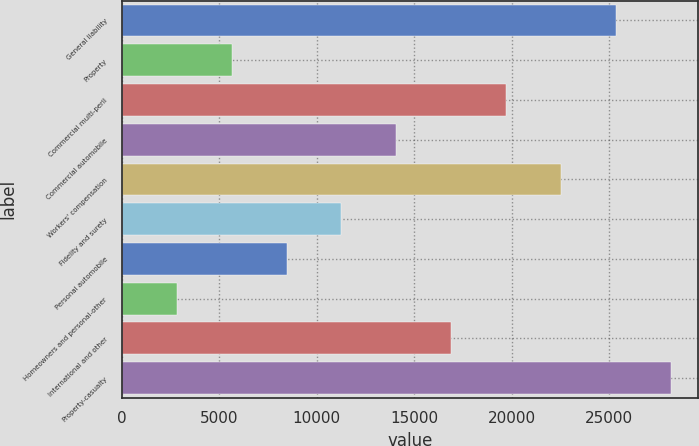Convert chart. <chart><loc_0><loc_0><loc_500><loc_500><bar_chart><fcel>General liability<fcel>Property<fcel>Commercial multi-peril<fcel>Commercial automobile<fcel>Workers' compensation<fcel>Fidelity and surety<fcel>Personal automobile<fcel>Homeowners and personal-other<fcel>International and other<fcel>Property-casualty<nl><fcel>25350.3<fcel>5640.4<fcel>19718.9<fcel>14087.5<fcel>22534.6<fcel>11271.8<fcel>8456.1<fcel>2824.7<fcel>16903.2<fcel>28166<nl></chart> 